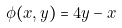Convert formula to latex. <formula><loc_0><loc_0><loc_500><loc_500>\phi ( x , y ) = 4 y - x</formula> 